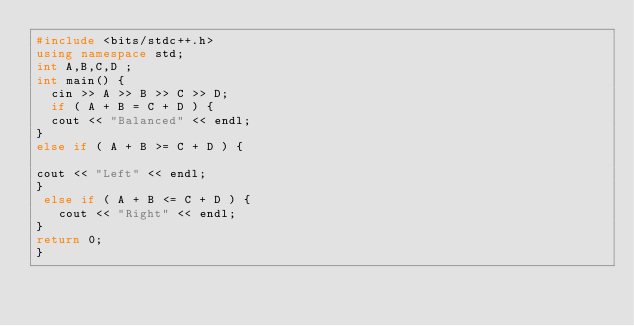Convert code to text. <code><loc_0><loc_0><loc_500><loc_500><_C++_>#include <bits/stdc++.h>
using namespace std;
int A,B,C,D ;
int main() {
  cin >> A >> B >> C >> D;
  if ( A + B = C + D ) {
  cout << "Balanced" << endl;
}
else if ( A + B >= C + D ) {
  
cout << "Left" << endl;
}
 else if ( A + B <= C + D ) {
   cout << "Right" << endl;
}
return 0;
}</code> 